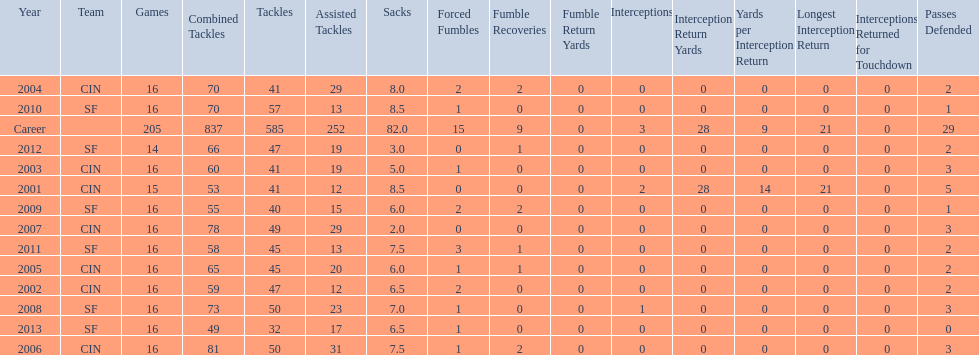Give me the full table as a dictionary. {'header': ['Year', 'Team', 'Games', 'Combined Tackles', 'Tackles', 'Assisted Tackles', 'Sacks', 'Forced Fumbles', 'Fumble Recoveries', 'Fumble Return Yards', 'Interceptions', 'Interception Return Yards', 'Yards per Interception Return', 'Longest Interception Return', 'Interceptions Returned for Touchdown', 'Passes Defended'], 'rows': [['2004', 'CIN', '16', '70', '41', '29', '8.0', '2', '2', '0', '0', '0', '0', '0', '0', '2'], ['2010', 'SF', '16', '70', '57', '13', '8.5', '1', '0', '0', '0', '0', '0', '0', '0', '1'], ['Career', '', '205', '837', '585', '252', '82.0', '15', '9', '0', '3', '28', '9', '21', '0', '29'], ['2012', 'SF', '14', '66', '47', '19', '3.0', '0', '1', '0', '0', '0', '0', '0', '0', '2'], ['2003', 'CIN', '16', '60', '41', '19', '5.0', '1', '0', '0', '0', '0', '0', '0', '0', '3'], ['2001', 'CIN', '15', '53', '41', '12', '8.5', '0', '0', '0', '2', '28', '14', '21', '0', '5'], ['2009', 'SF', '16', '55', '40', '15', '6.0', '2', '2', '0', '0', '0', '0', '0', '0', '1'], ['2007', 'CIN', '16', '78', '49', '29', '2.0', '0', '0', '0', '0', '0', '0', '0', '0', '3'], ['2011', 'SF', '16', '58', '45', '13', '7.5', '3', '1', '0', '0', '0', '0', '0', '0', '2'], ['2005', 'CIN', '16', '65', '45', '20', '6.0', '1', '1', '0', '0', '0', '0', '0', '0', '2'], ['2002', 'CIN', '16', '59', '47', '12', '6.5', '2', '0', '0', '0', '0', '0', '0', '0', '2'], ['2008', 'SF', '16', '73', '50', '23', '7.0', '1', '0', '0', '1', '0', '0', '0', '0', '3'], ['2013', 'SF', '16', '49', '32', '17', '6.5', '1', '0', '0', '0', '0', '0', '0', '0', '0'], ['2006', 'CIN', '16', '81', '50', '31', '7.5', '1', '2', '0', '0', '0', '0', '0', '0', '3']]} How many consecutive seasons has he played sixteen games? 10. 